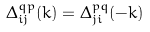<formula> <loc_0><loc_0><loc_500><loc_500>\Delta _ { i j } ^ { q p } ( k ) = \Delta _ { j i } ^ { p q } ( - k )</formula> 